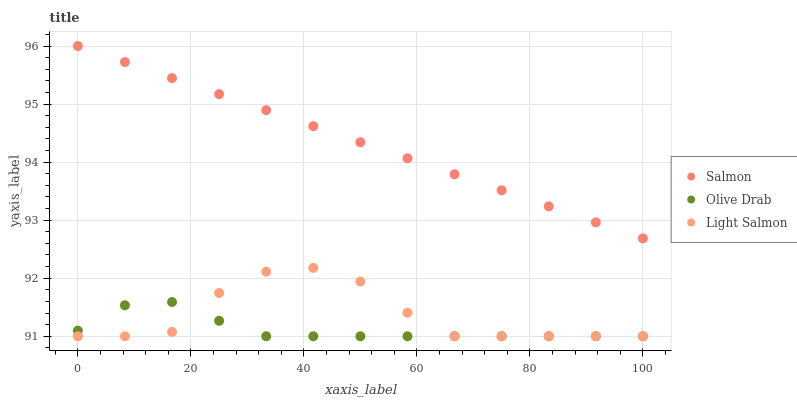Does Olive Drab have the minimum area under the curve?
Answer yes or no. Yes. Does Salmon have the maximum area under the curve?
Answer yes or no. Yes. Does Salmon have the minimum area under the curve?
Answer yes or no. No. Does Olive Drab have the maximum area under the curve?
Answer yes or no. No. Is Salmon the smoothest?
Answer yes or no. Yes. Is Light Salmon the roughest?
Answer yes or no. Yes. Is Olive Drab the smoothest?
Answer yes or no. No. Is Olive Drab the roughest?
Answer yes or no. No. Does Light Salmon have the lowest value?
Answer yes or no. Yes. Does Salmon have the lowest value?
Answer yes or no. No. Does Salmon have the highest value?
Answer yes or no. Yes. Does Olive Drab have the highest value?
Answer yes or no. No. Is Light Salmon less than Salmon?
Answer yes or no. Yes. Is Salmon greater than Light Salmon?
Answer yes or no. Yes. Does Olive Drab intersect Light Salmon?
Answer yes or no. Yes. Is Olive Drab less than Light Salmon?
Answer yes or no. No. Is Olive Drab greater than Light Salmon?
Answer yes or no. No. Does Light Salmon intersect Salmon?
Answer yes or no. No. 